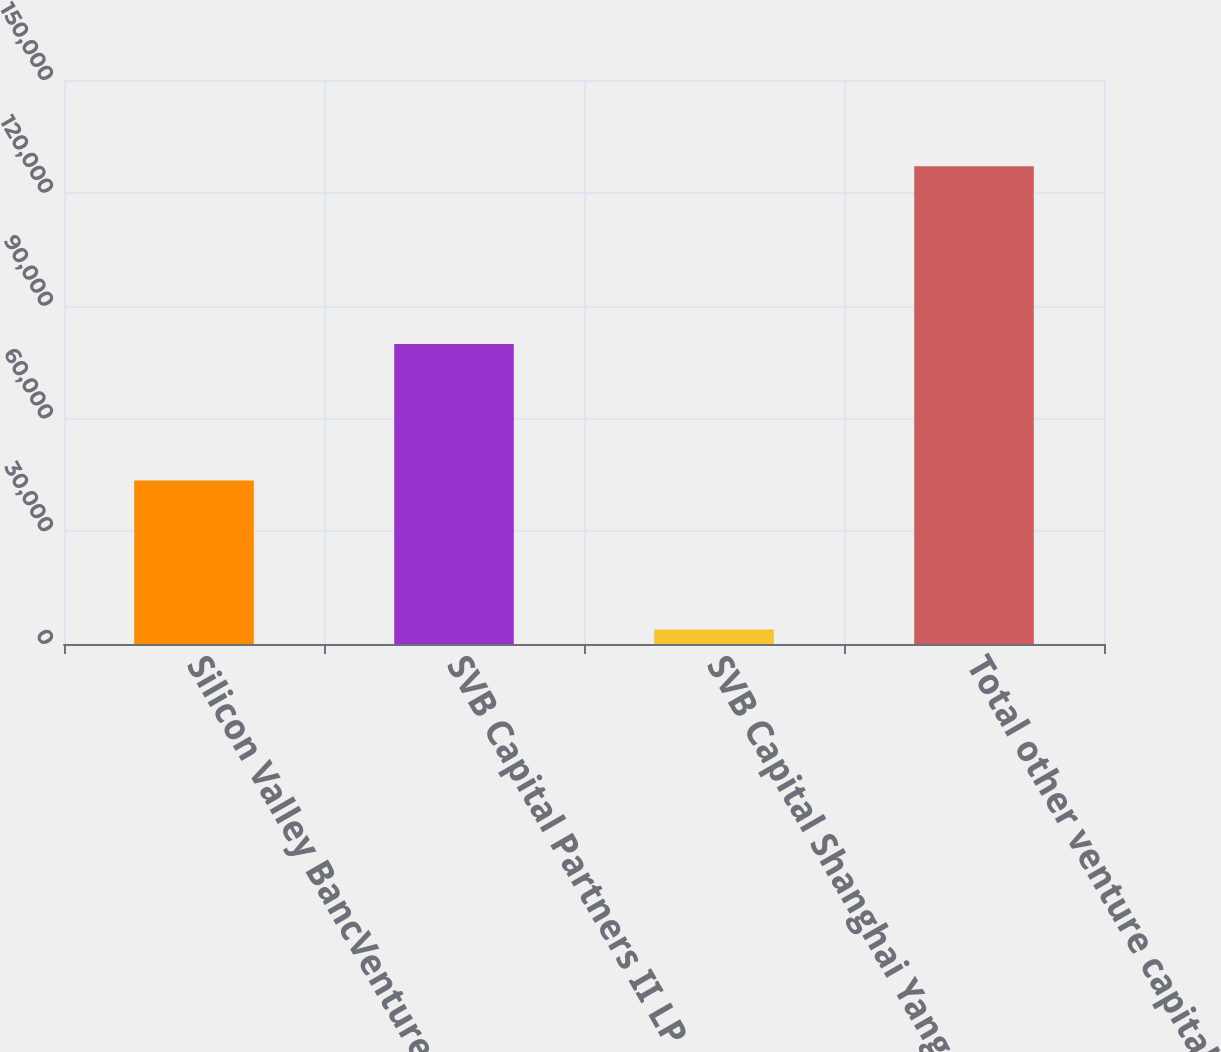<chart> <loc_0><loc_0><loc_500><loc_500><bar_chart><fcel>Silicon Valley BancVentures LP<fcel>SVB Capital Partners II LP<fcel>SVB Capital Shanghai Yangpu<fcel>Total other venture capital<nl><fcel>43493<fcel>79761<fcel>3837<fcel>127091<nl></chart> 